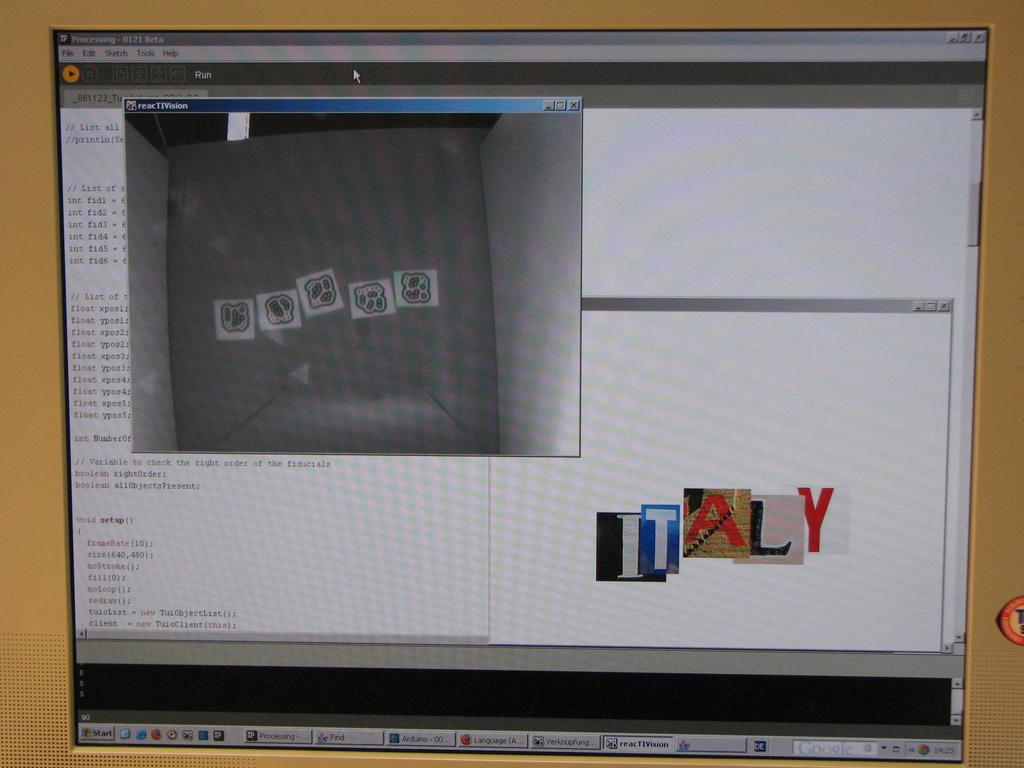<image>
Write a terse but informative summary of the picture. The country that appears on this computer screen is Italy. 